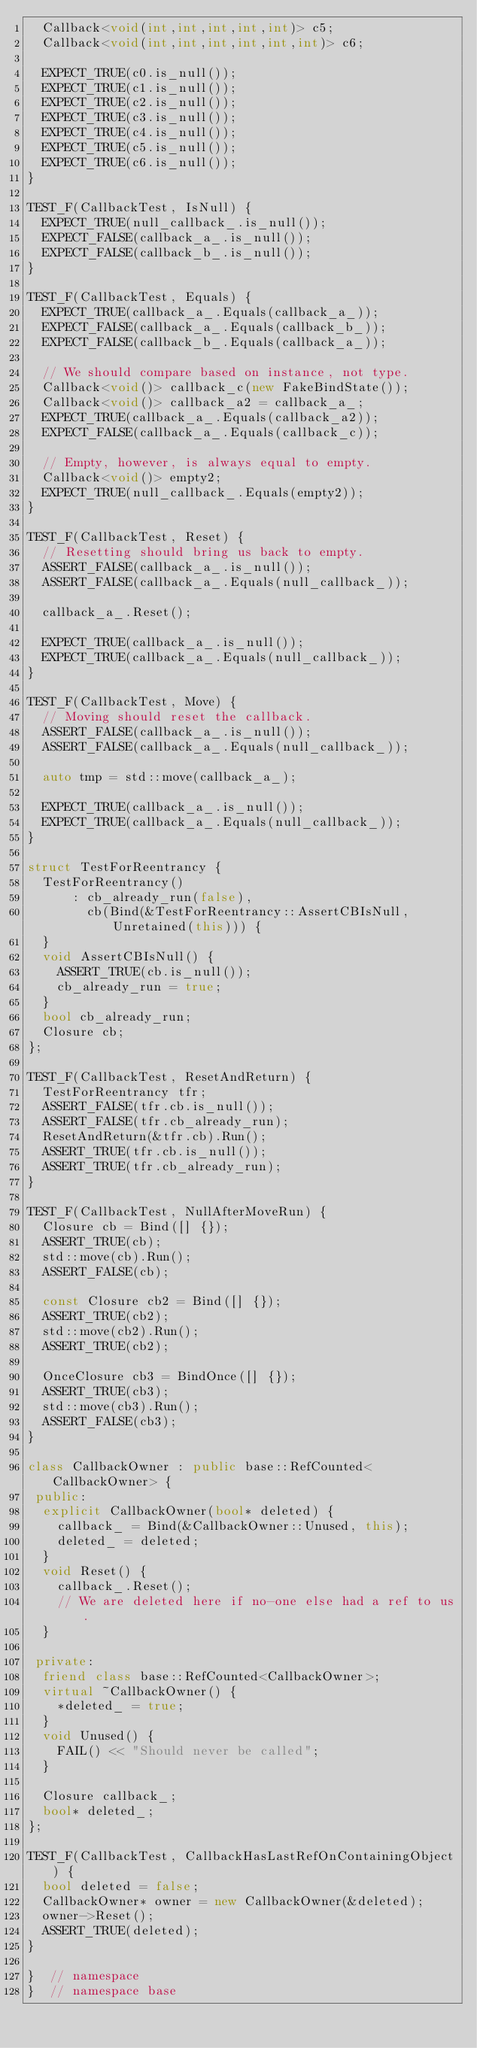Convert code to text. <code><loc_0><loc_0><loc_500><loc_500><_C++_>  Callback<void(int,int,int,int,int)> c5;
  Callback<void(int,int,int,int,int,int)> c6;

  EXPECT_TRUE(c0.is_null());
  EXPECT_TRUE(c1.is_null());
  EXPECT_TRUE(c2.is_null());
  EXPECT_TRUE(c3.is_null());
  EXPECT_TRUE(c4.is_null());
  EXPECT_TRUE(c5.is_null());
  EXPECT_TRUE(c6.is_null());
}

TEST_F(CallbackTest, IsNull) {
  EXPECT_TRUE(null_callback_.is_null());
  EXPECT_FALSE(callback_a_.is_null());
  EXPECT_FALSE(callback_b_.is_null());
}

TEST_F(CallbackTest, Equals) {
  EXPECT_TRUE(callback_a_.Equals(callback_a_));
  EXPECT_FALSE(callback_a_.Equals(callback_b_));
  EXPECT_FALSE(callback_b_.Equals(callback_a_));

  // We should compare based on instance, not type.
  Callback<void()> callback_c(new FakeBindState());
  Callback<void()> callback_a2 = callback_a_;
  EXPECT_TRUE(callback_a_.Equals(callback_a2));
  EXPECT_FALSE(callback_a_.Equals(callback_c));

  // Empty, however, is always equal to empty.
  Callback<void()> empty2;
  EXPECT_TRUE(null_callback_.Equals(empty2));
}

TEST_F(CallbackTest, Reset) {
  // Resetting should bring us back to empty.
  ASSERT_FALSE(callback_a_.is_null());
  ASSERT_FALSE(callback_a_.Equals(null_callback_));

  callback_a_.Reset();

  EXPECT_TRUE(callback_a_.is_null());
  EXPECT_TRUE(callback_a_.Equals(null_callback_));
}

TEST_F(CallbackTest, Move) {
  // Moving should reset the callback.
  ASSERT_FALSE(callback_a_.is_null());
  ASSERT_FALSE(callback_a_.Equals(null_callback_));

  auto tmp = std::move(callback_a_);

  EXPECT_TRUE(callback_a_.is_null());
  EXPECT_TRUE(callback_a_.Equals(null_callback_));
}

struct TestForReentrancy {
  TestForReentrancy()
      : cb_already_run(false),
        cb(Bind(&TestForReentrancy::AssertCBIsNull, Unretained(this))) {
  }
  void AssertCBIsNull() {
    ASSERT_TRUE(cb.is_null());
    cb_already_run = true;
  }
  bool cb_already_run;
  Closure cb;
};

TEST_F(CallbackTest, ResetAndReturn) {
  TestForReentrancy tfr;
  ASSERT_FALSE(tfr.cb.is_null());
  ASSERT_FALSE(tfr.cb_already_run);
  ResetAndReturn(&tfr.cb).Run();
  ASSERT_TRUE(tfr.cb.is_null());
  ASSERT_TRUE(tfr.cb_already_run);
}

TEST_F(CallbackTest, NullAfterMoveRun) {
  Closure cb = Bind([] {});
  ASSERT_TRUE(cb);
  std::move(cb).Run();
  ASSERT_FALSE(cb);

  const Closure cb2 = Bind([] {});
  ASSERT_TRUE(cb2);
  std::move(cb2).Run();
  ASSERT_TRUE(cb2);

  OnceClosure cb3 = BindOnce([] {});
  ASSERT_TRUE(cb3);
  std::move(cb3).Run();
  ASSERT_FALSE(cb3);
}

class CallbackOwner : public base::RefCounted<CallbackOwner> {
 public:
  explicit CallbackOwner(bool* deleted) {
    callback_ = Bind(&CallbackOwner::Unused, this);
    deleted_ = deleted;
  }
  void Reset() {
    callback_.Reset();
    // We are deleted here if no-one else had a ref to us.
  }

 private:
  friend class base::RefCounted<CallbackOwner>;
  virtual ~CallbackOwner() {
    *deleted_ = true;
  }
  void Unused() {
    FAIL() << "Should never be called";
  }

  Closure callback_;
  bool* deleted_;
};

TEST_F(CallbackTest, CallbackHasLastRefOnContainingObject) {
  bool deleted = false;
  CallbackOwner* owner = new CallbackOwner(&deleted);
  owner->Reset();
  ASSERT_TRUE(deleted);
}

}  // namespace
}  // namespace base
</code> 